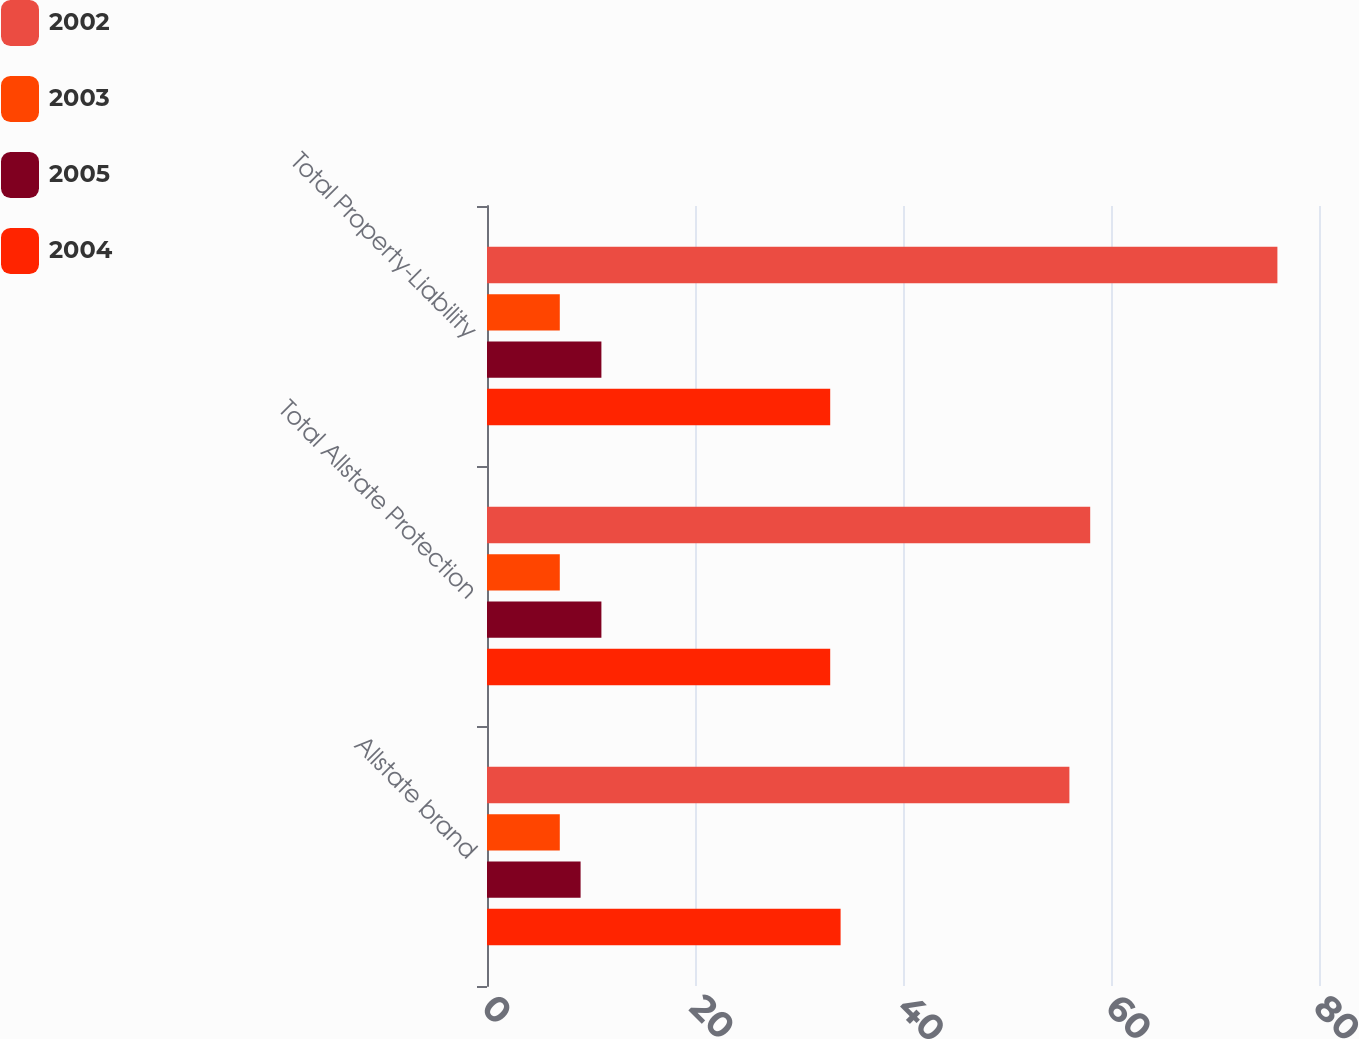Convert chart to OTSL. <chart><loc_0><loc_0><loc_500><loc_500><stacked_bar_chart><ecel><fcel>Allstate brand<fcel>Total Allstate Protection<fcel>Total Property-Liability<nl><fcel>2002<fcel>56<fcel>58<fcel>76<nl><fcel>2003<fcel>7<fcel>7<fcel>7<nl><fcel>2005<fcel>9<fcel>11<fcel>11<nl><fcel>2004<fcel>34<fcel>33<fcel>33<nl></chart> 